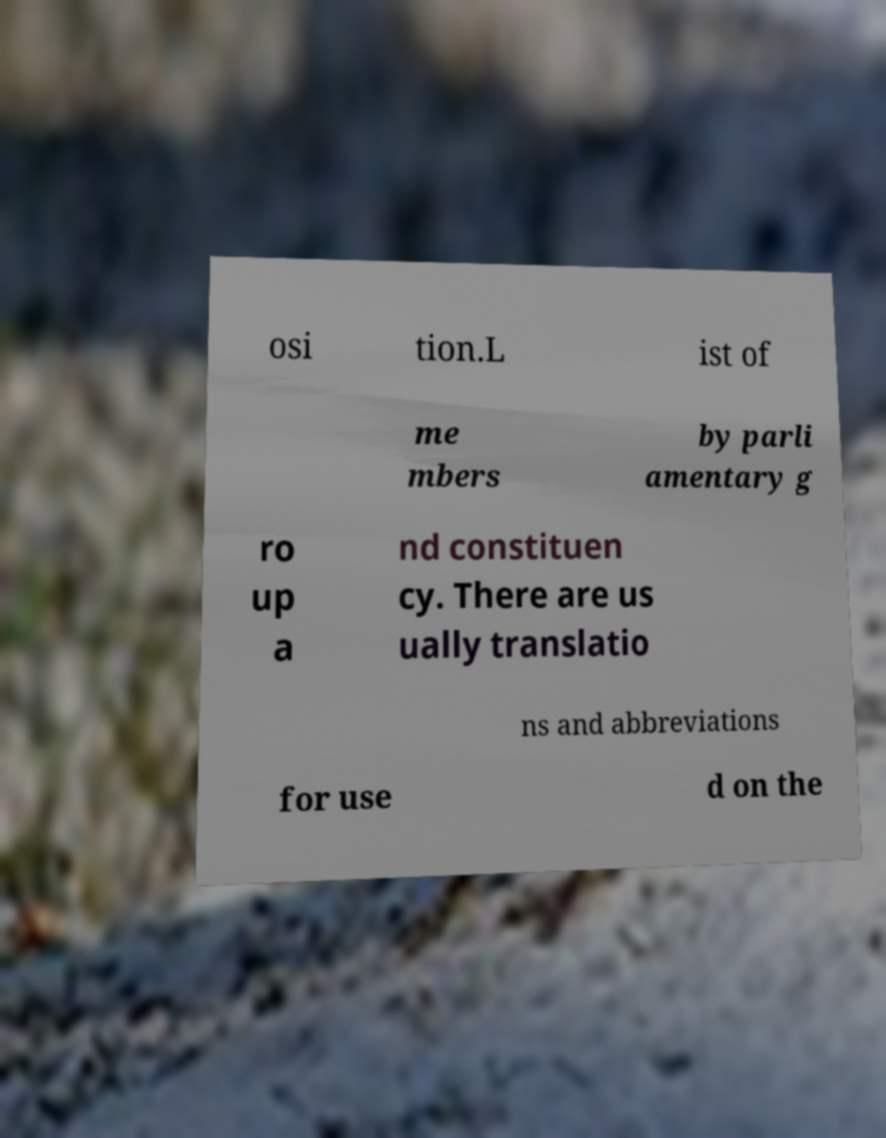Could you assist in decoding the text presented in this image and type it out clearly? osi tion.L ist of me mbers by parli amentary g ro up a nd constituen cy. There are us ually translatio ns and abbreviations for use d on the 